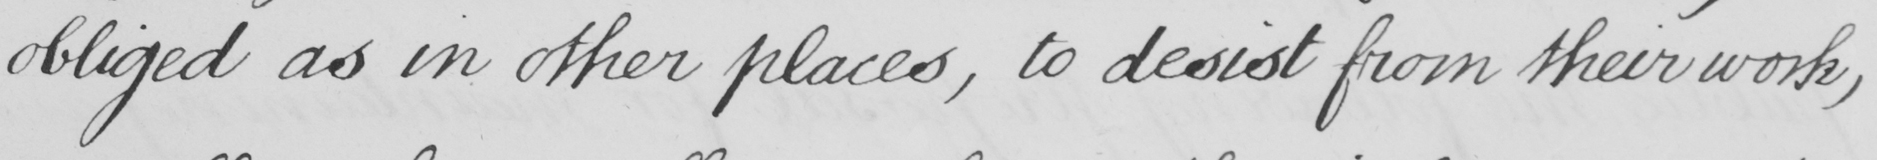Please transcribe the handwritten text in this image. obliged as in other places, to desist from their work, 